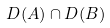Convert formula to latex. <formula><loc_0><loc_0><loc_500><loc_500>D ( A ) \cap D ( B )</formula> 